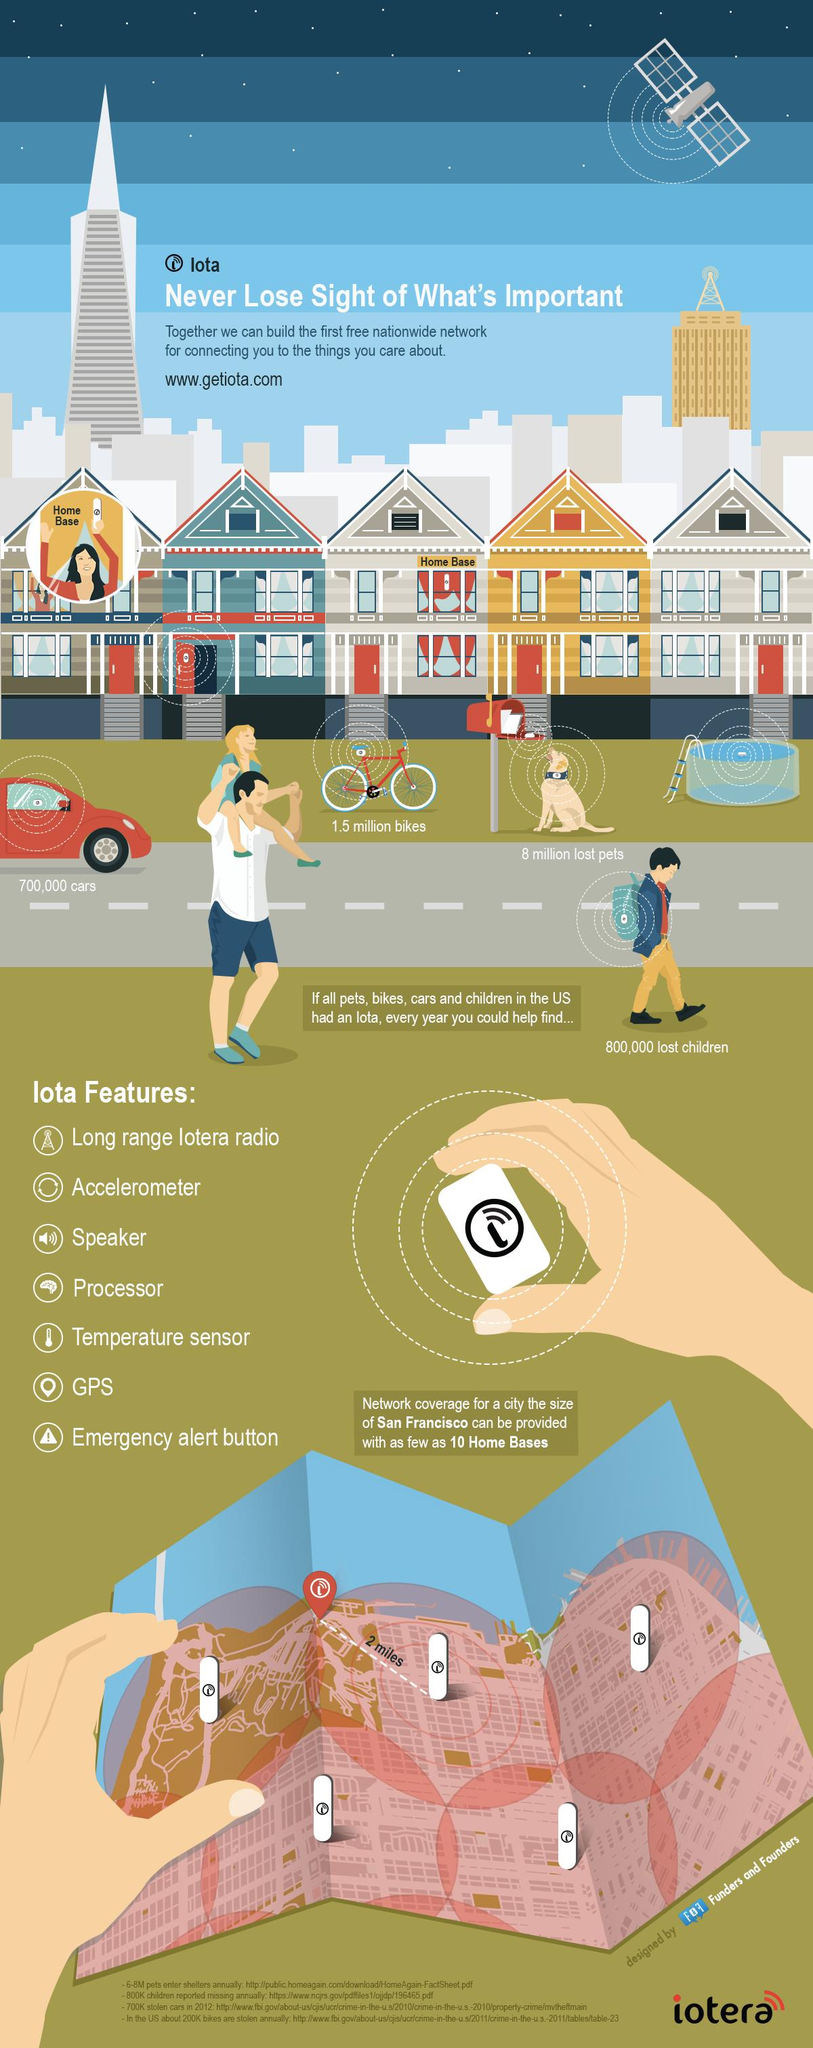Give some essential details in this illustration. The number of lost pets was greater than the number of lost bikes by 6.5 million. There are a total of 5 images of Iota home bases displayed on the map. The iota Homebase provides a maximum network coverage of 2 miles. GPS and an emergency alert button are the last two features of Iota mentioned in this article. I have observed that the contents of the child's bag include the letter iota. 